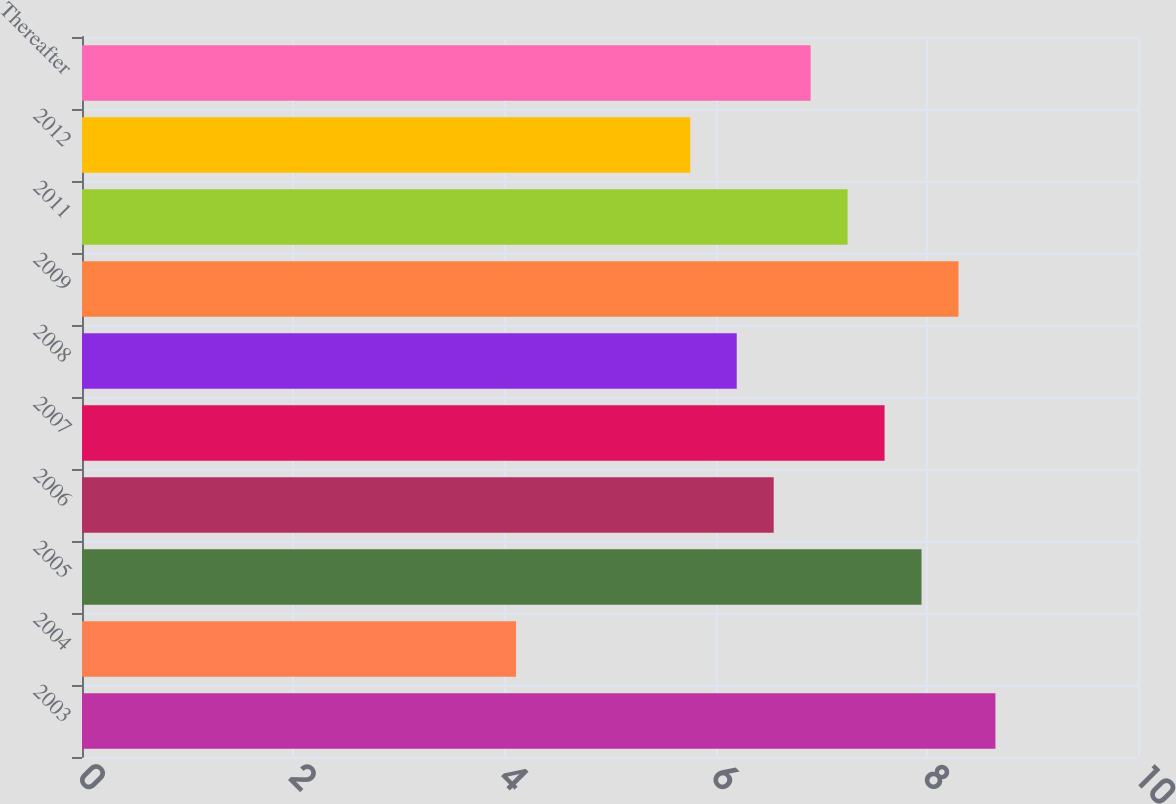Convert chart. <chart><loc_0><loc_0><loc_500><loc_500><bar_chart><fcel>2003<fcel>2004<fcel>2005<fcel>2006<fcel>2007<fcel>2008<fcel>2009<fcel>2011<fcel>2012<fcel>Thereafter<nl><fcel>8.65<fcel>4.11<fcel>7.95<fcel>6.55<fcel>7.6<fcel>6.2<fcel>8.3<fcel>7.25<fcel>5.76<fcel>6.9<nl></chart> 